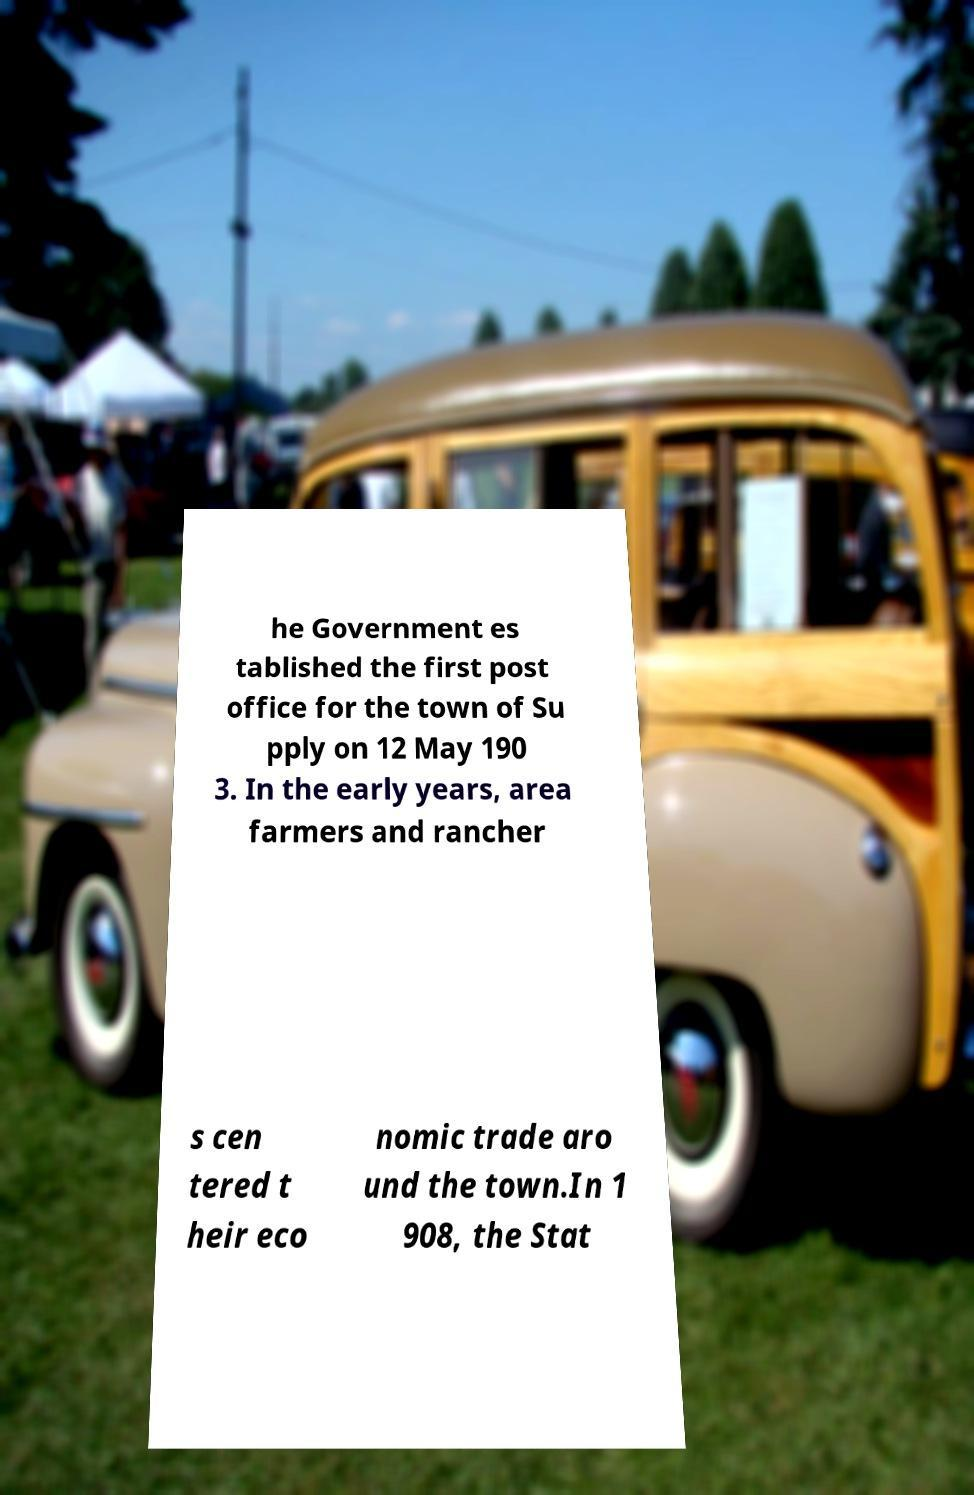What messages or text are displayed in this image? I need them in a readable, typed format. he Government es tablished the first post office for the town of Su pply on 12 May 190 3. In the early years, area farmers and rancher s cen tered t heir eco nomic trade aro und the town.In 1 908, the Stat 